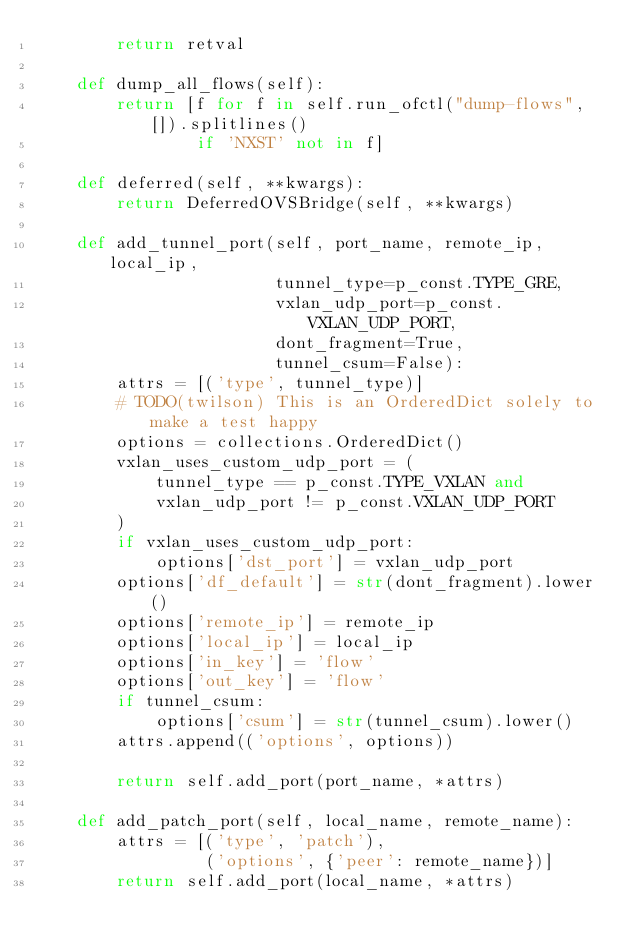Convert code to text. <code><loc_0><loc_0><loc_500><loc_500><_Python_>        return retval

    def dump_all_flows(self):
        return [f for f in self.run_ofctl("dump-flows", []).splitlines()
                if 'NXST' not in f]

    def deferred(self, **kwargs):
        return DeferredOVSBridge(self, **kwargs)

    def add_tunnel_port(self, port_name, remote_ip, local_ip,
                        tunnel_type=p_const.TYPE_GRE,
                        vxlan_udp_port=p_const.VXLAN_UDP_PORT,
                        dont_fragment=True,
                        tunnel_csum=False):
        attrs = [('type', tunnel_type)]
        # TODO(twilson) This is an OrderedDict solely to make a test happy
        options = collections.OrderedDict()
        vxlan_uses_custom_udp_port = (
            tunnel_type == p_const.TYPE_VXLAN and
            vxlan_udp_port != p_const.VXLAN_UDP_PORT
        )
        if vxlan_uses_custom_udp_port:
            options['dst_port'] = vxlan_udp_port
        options['df_default'] = str(dont_fragment).lower()
        options['remote_ip'] = remote_ip
        options['local_ip'] = local_ip
        options['in_key'] = 'flow'
        options['out_key'] = 'flow'
        if tunnel_csum:
            options['csum'] = str(tunnel_csum).lower()
        attrs.append(('options', options))

        return self.add_port(port_name, *attrs)

    def add_patch_port(self, local_name, remote_name):
        attrs = [('type', 'patch'),
                 ('options', {'peer': remote_name})]
        return self.add_port(local_name, *attrs)
</code> 